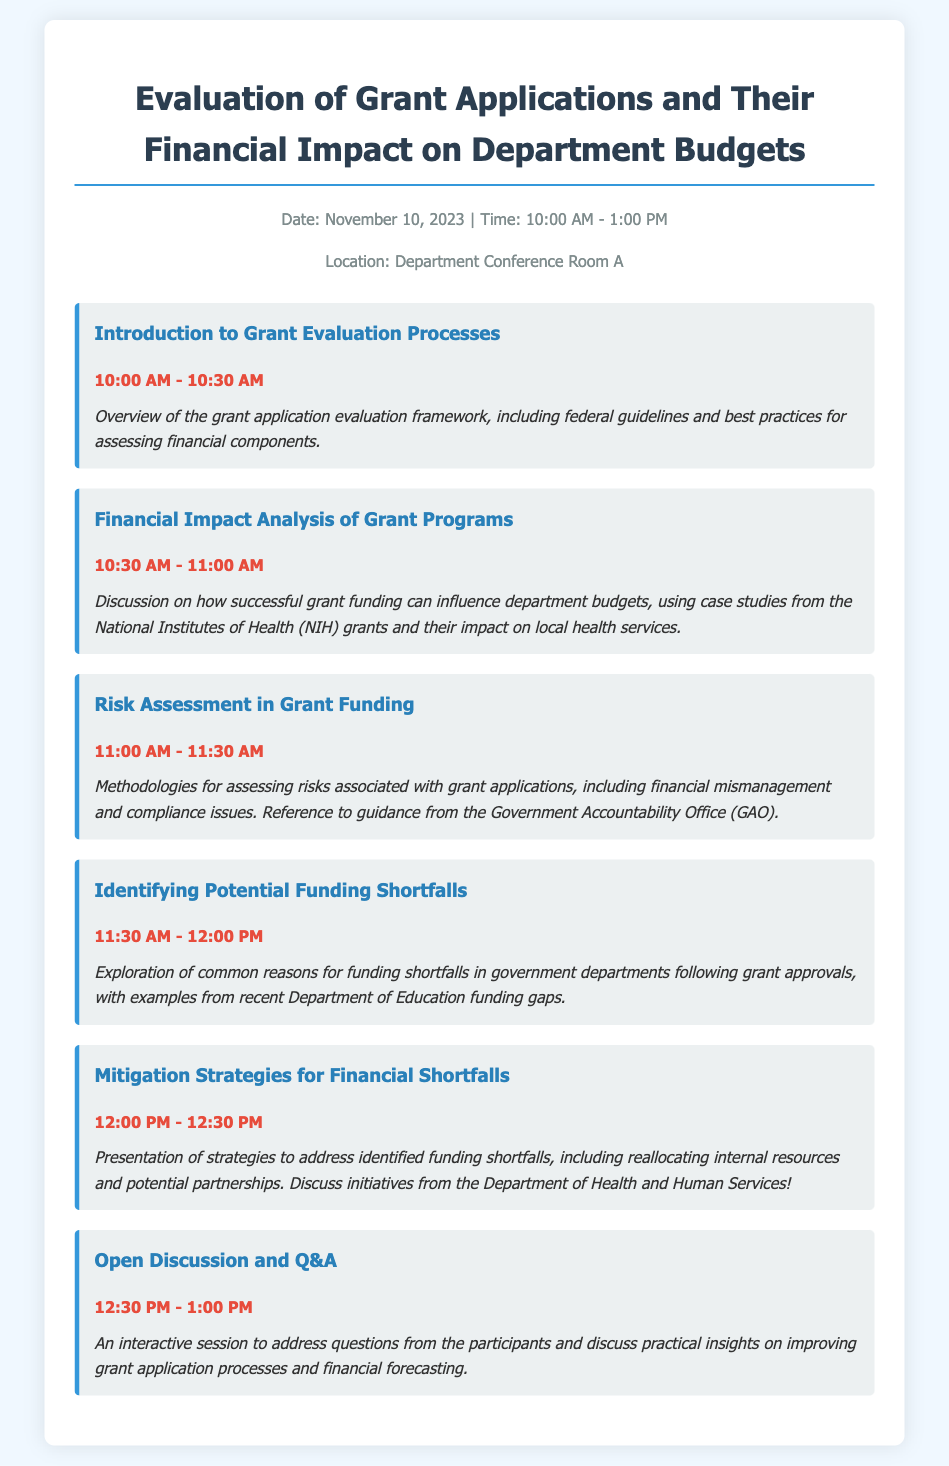What is the date of the agenda? The agenda specifies the date as November 10, 2023.
Answer: November 10, 2023 What time does the session on Financial Impact Analysis start? The session begins at 10:30 AM.
Answer: 10:30 AM Who provides guidance on risk assessment methodologies? The document mentions the Government Accountability Office (GAO) as a reference for risk assessment methodologies.
Answer: Government Accountability Office (GAO) What is a common reason for funding shortfalls discussed in the document? The document explores common reasons for funding shortfalls in government departments following grant approvals, specifically mentioning recent Department of Education funding gaps.
Answer: Department of Education funding gaps What is the focus of the open discussion session? The open discussion session focuses on addressing questions from participants and discussing practical insights on improving grant application processes and financial forecasting.
Answer: Improving grant application processes and financial forecasting How long is the introduction to grant evaluation processes? The introduction to grant evaluation processes lasts for 30 minutes.
Answer: 30 minutes What strategy is presented to mitigate financial shortfalls? The document presents the strategy of reallocating internal resources to address identified funding shortfalls.
Answer: Reallocating internal resources What is the last item on the agenda? The last item on the agenda is the open discussion and Q&A session.
Answer: Open Discussion and Q&A What color is used for the main heading of the document? The main heading uses the color #2c3e50.
Answer: #2c3e50 